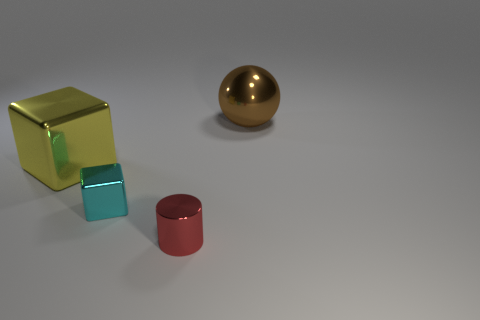Add 3 metallic cylinders. How many objects exist? 7 Add 3 purple metal cylinders. How many purple metal cylinders exist? 3 Subtract 0 yellow balls. How many objects are left? 4 Subtract all yellow shiny things. Subtract all large rubber cylinders. How many objects are left? 3 Add 2 shiny cylinders. How many shiny cylinders are left? 3 